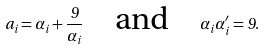Convert formula to latex. <formula><loc_0><loc_0><loc_500><loc_500>a _ { i } = \alpha _ { i } + \frac { 9 } { \alpha _ { i } } \quad \text {and} \quad \alpha _ { i } \alpha ^ { \prime } _ { i } = 9 .</formula> 